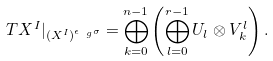<formula> <loc_0><loc_0><loc_500><loc_500>T X ^ { I } | _ { ( X ^ { I } ) ^ { \epsilon _ { \ g } \sigma } } = \bigoplus _ { k = 0 } ^ { n - 1 } \left ( \bigoplus _ { l = 0 } ^ { r - 1 } U _ { l } \otimes V ^ { l } _ { k } \right ) .</formula> 